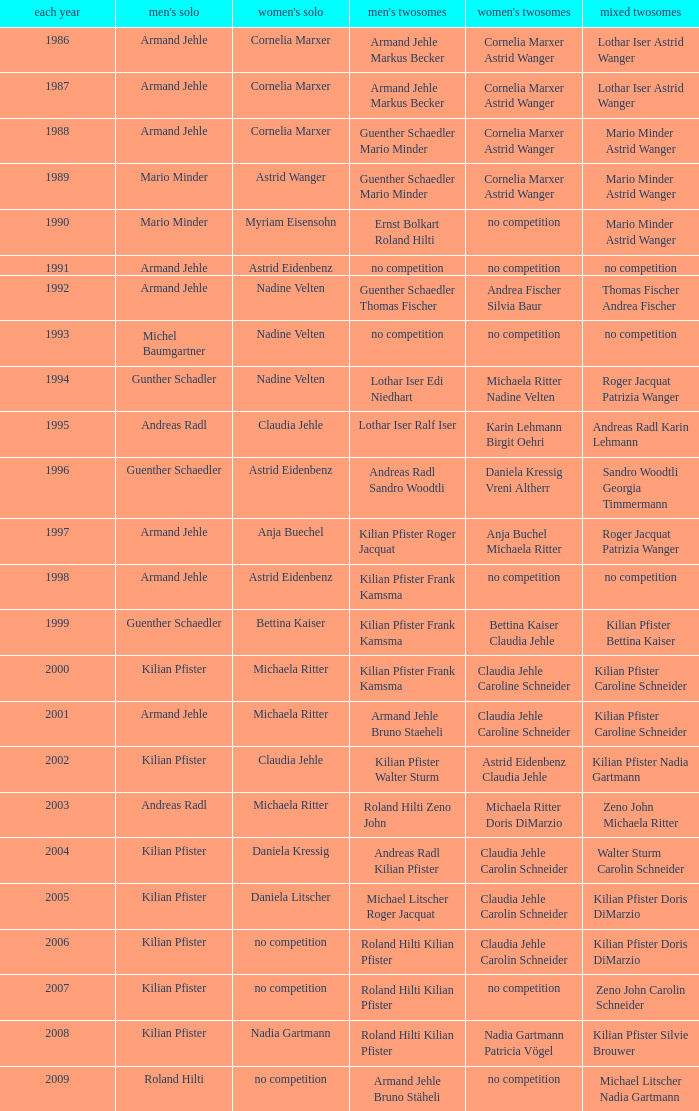In 1987 who was the mens singles Armand Jehle. 